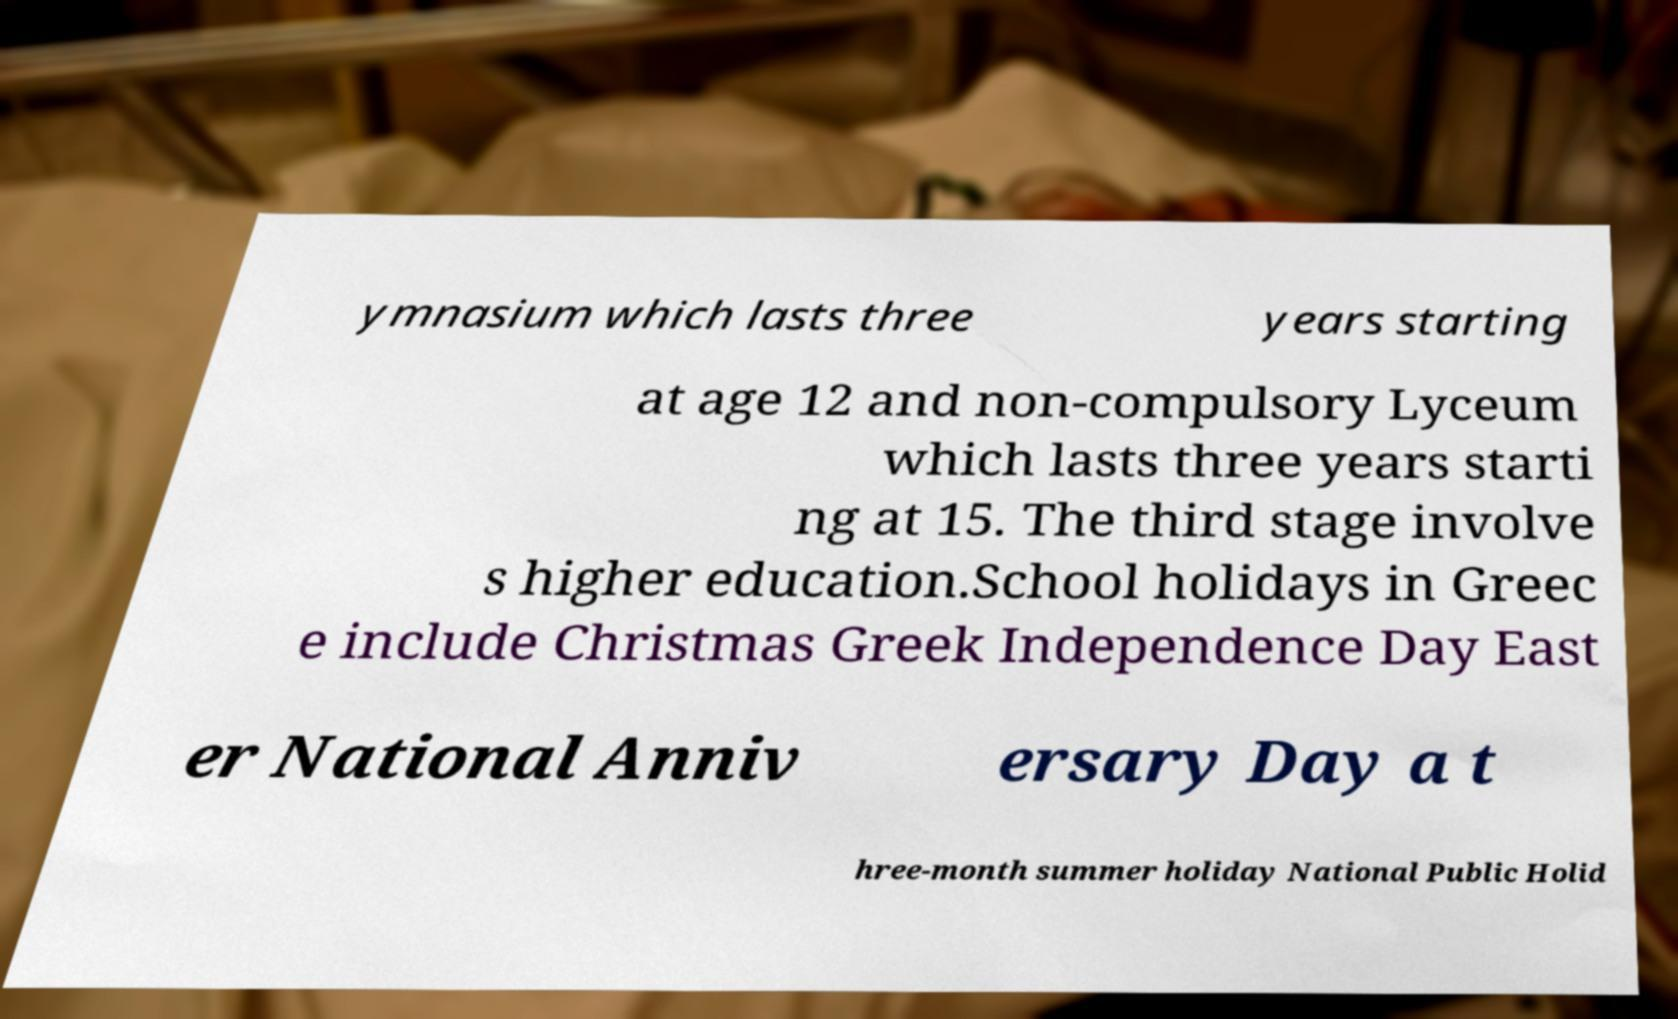Could you assist in decoding the text presented in this image and type it out clearly? ymnasium which lasts three years starting at age 12 and non-compulsory Lyceum which lasts three years starti ng at 15. The third stage involve s higher education.School holidays in Greec e include Christmas Greek Independence Day East er National Anniv ersary Day a t hree-month summer holiday National Public Holid 